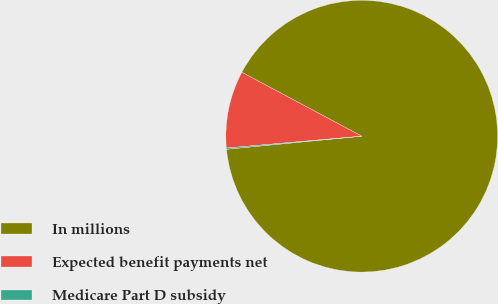Convert chart. <chart><loc_0><loc_0><loc_500><loc_500><pie_chart><fcel>In millions<fcel>Expected benefit payments net<fcel>Medicare Part D subsidy<nl><fcel>90.68%<fcel>9.19%<fcel>0.14%<nl></chart> 